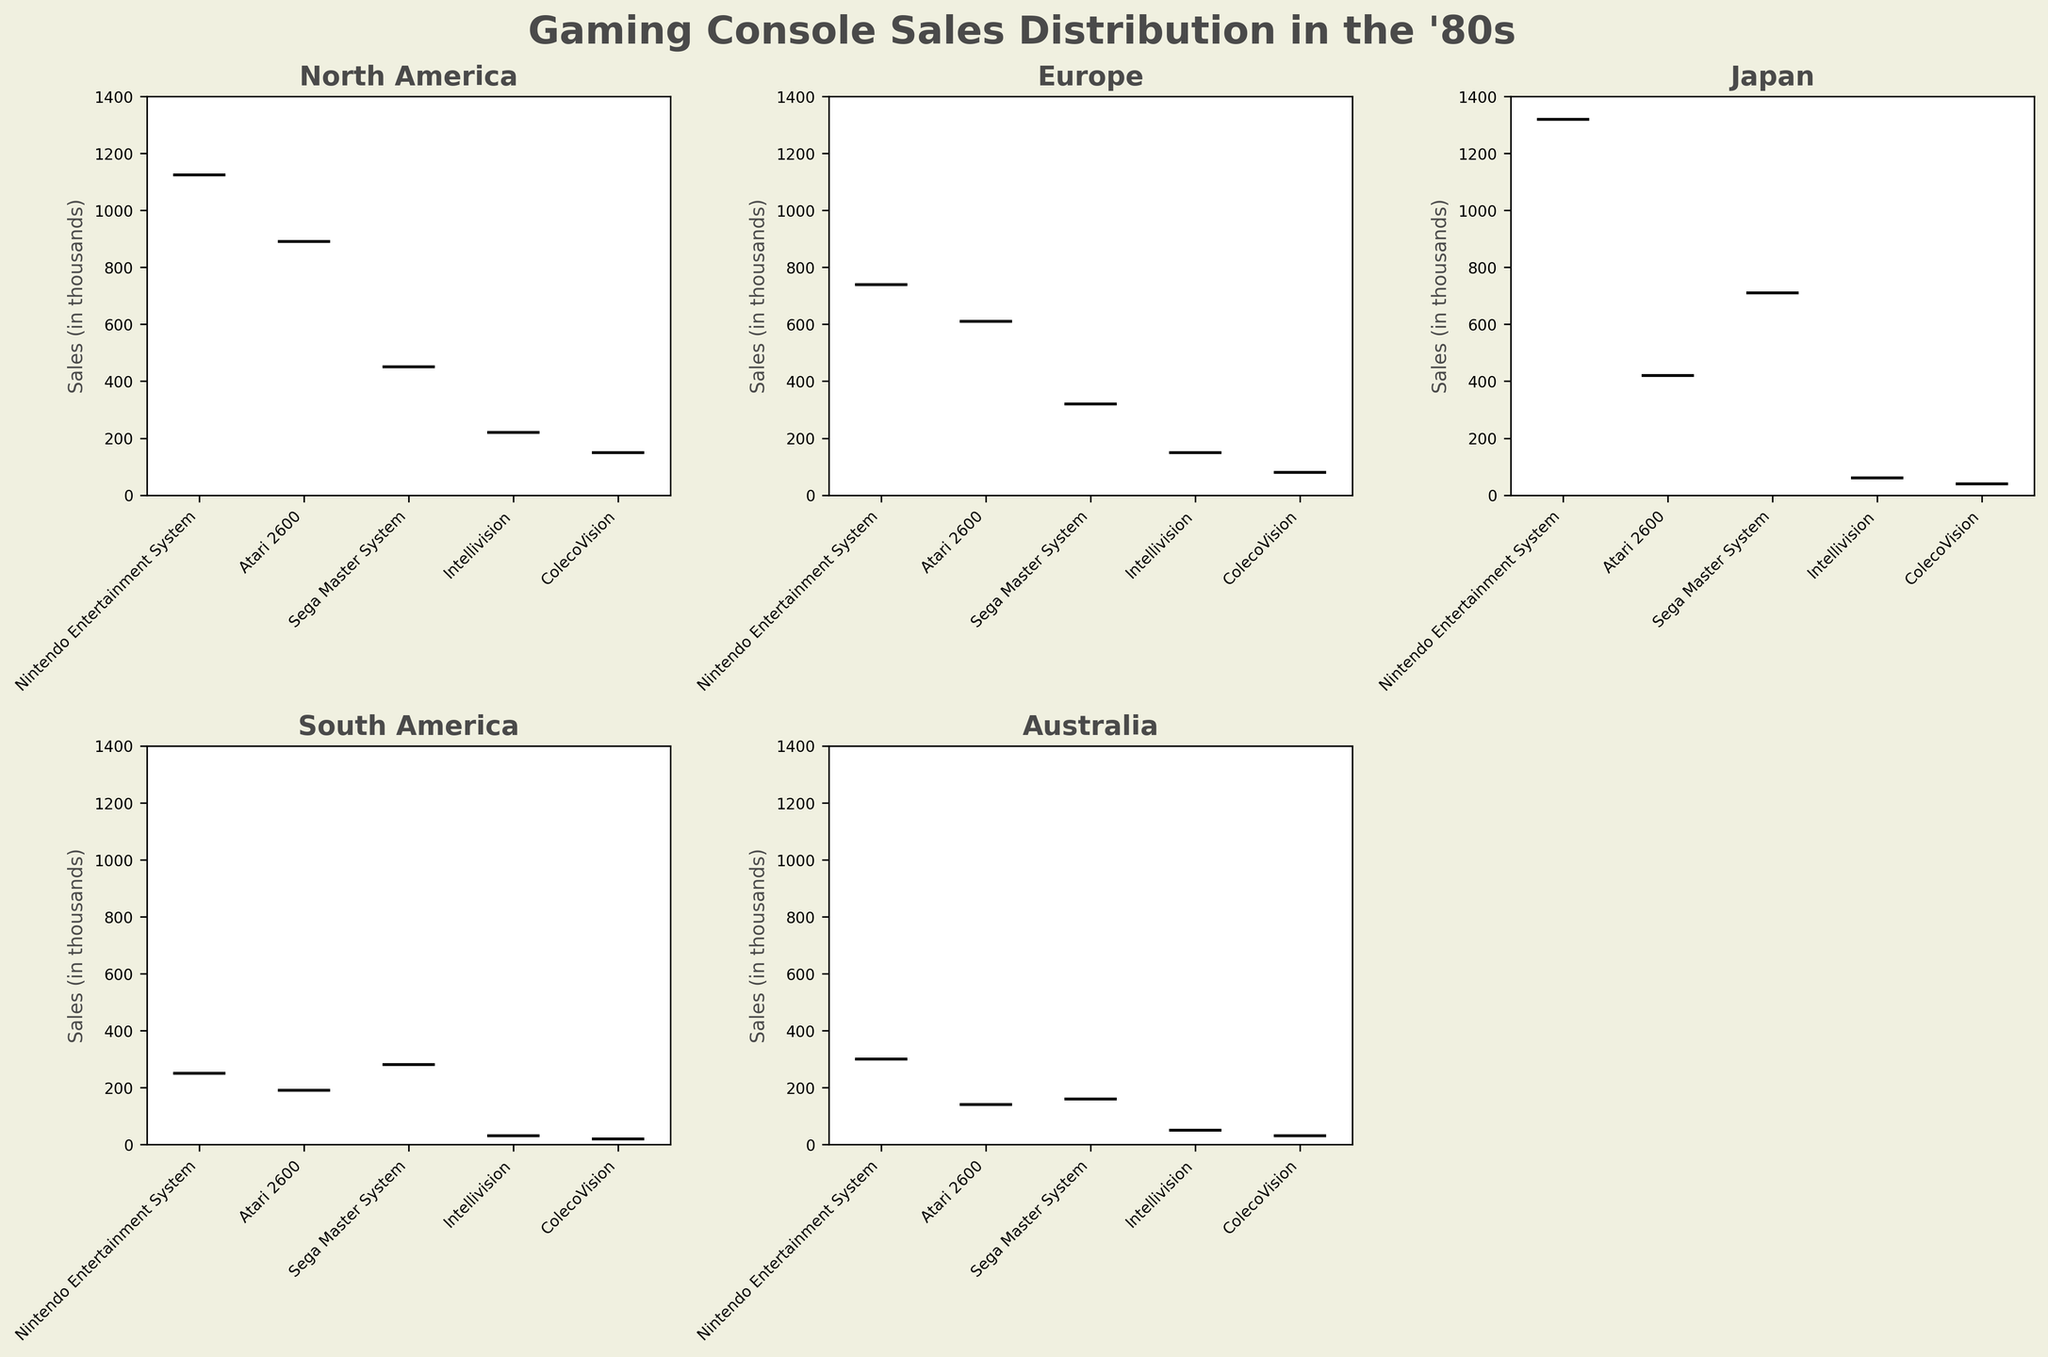How many regions are represented in the figure? The figure contains multiple subplots, each representing a different region. By counting the subplots with titles indicating regions, we can determine the total number of regions.
Answer: 5 Which console has the highest median sales in North America? We look at the boxplot for North America and identify the console with the highest median line, which indicates the median sales value.
Answer: Nintendo Entertainment System Among the regions, which one shows the lowest maximum sales for the Atari 2600? We examine the "Atari 2600" boxplots across all regions and locate the maximum values (the top whiskers), then compare them to find the region with the lowest maximum.
Answer: Australia How do the median sales of the Sega Master System compare between Europe and Japan? To answer this, we look at the median lines within the Sega Master System boxplots for both Europe and Japan and compare their positions.
Answer: Japan has a higher median Which region shows the most variability in sales for the Nintendo Entertainment System? Variability can be assessed by looking at the range covered by the box and whiskers of each Nintendo Entertainment System boxplot across the regions. The region with the largest interquartile range and longest whiskers indicates the most variability.
Answer: Japan What's the sales range (difference between max and min) for the Intellivision in Australia? By examining the Intellivision boxplot for Australia, we identify the maximum and minimum sales values (top and bottom whiskers) and subtract the minimum from the maximum to find the range.
Answer: 50 (50 - 0) Which console has the smallest interquartile range (IQR) in South America? The interquartile range (IQR) represents the middle 50% of the data. We look at the height of the boxes (IQR) for each console in South America and find the smallest one.
Answer: Intellivision Which region has the highest overall median sales across all consoles combined? To find this, we visually compare the median lines (black lines within the boxes) across all consoles in each region and determine which region has the highest median sales overall.
Answer: Japan Does the ColecoVision show any outliers in its sales data for North America? Outliers in a boxplot are represented by dots outside the whiskers. We check the North America subplot for any dots outside the whiskers in the ColecoVision section.
Answer: Yes Which region has the smallest variation (shortest box height) for the Atari 2600 sales? By analyzing the height of the boxes for the Atari 2600 sales across all regions, we identify the region with the shortest box, indicating the least variation.
Answer: Australia 